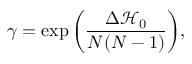<formula> <loc_0><loc_0><loc_500><loc_500>\gamma = \exp { \left ( \frac { \Delta \mathcal { H } _ { 0 } } { N ( N - 1 ) } \right ) } ,</formula> 